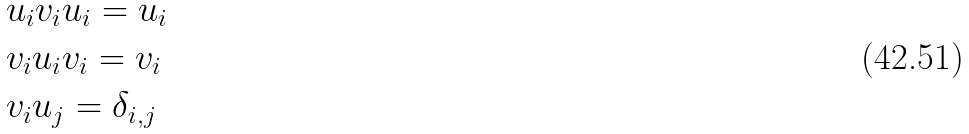Convert formula to latex. <formula><loc_0><loc_0><loc_500><loc_500>& u _ { i } v _ { i } u _ { i } = u _ { i } \\ & v _ { i } u _ { i } v _ { i } = v _ { i } \\ & v _ { i } u _ { j } = \delta _ { i , j }</formula> 